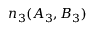Convert formula to latex. <formula><loc_0><loc_0><loc_500><loc_500>n _ { 3 } ( A _ { 3 } , B _ { 3 } )</formula> 